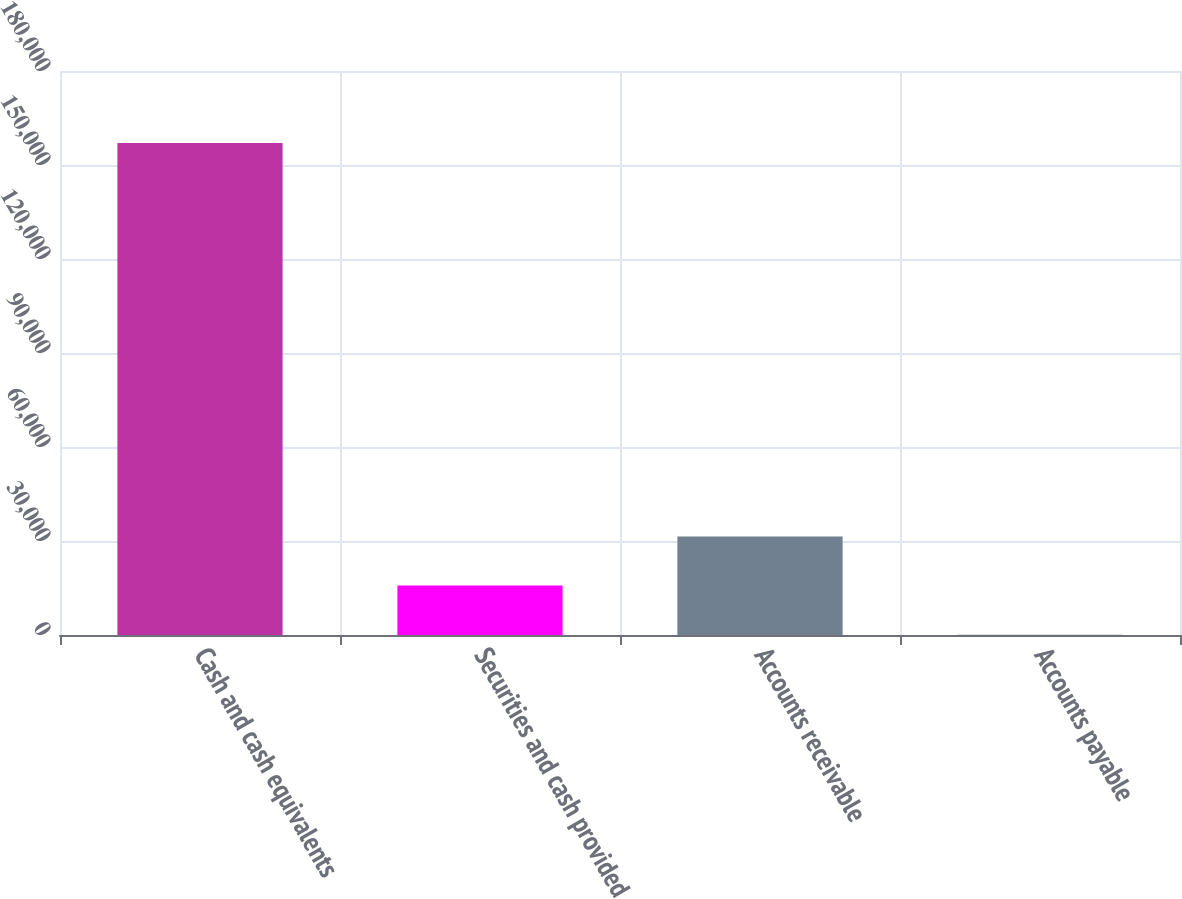<chart> <loc_0><loc_0><loc_500><loc_500><bar_chart><fcel>Cash and cash equivalents<fcel>Securities and cash provided<fcel>Accounts receivable<fcel>Accounts payable<nl><fcel>156982<fcel>15775.6<fcel>31465.2<fcel>86<nl></chart> 